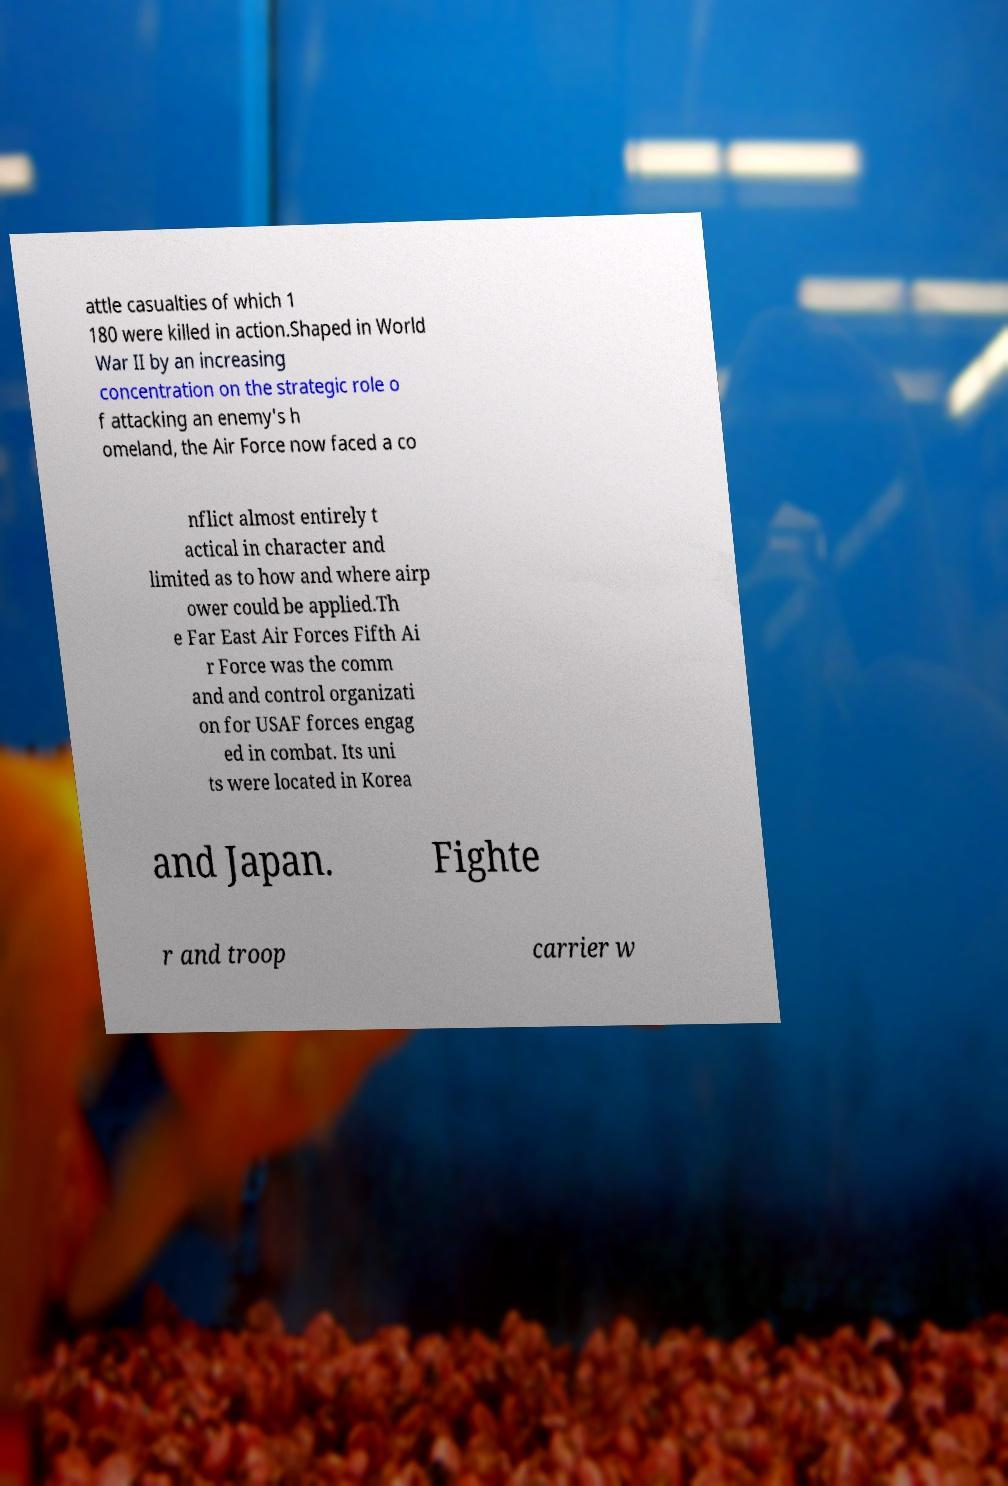Can you read and provide the text displayed in the image?This photo seems to have some interesting text. Can you extract and type it out for me? attle casualties of which 1 180 were killed in action.Shaped in World War II by an increasing concentration on the strategic role o f attacking an enemy's h omeland, the Air Force now faced a co nflict almost entirely t actical in character and limited as to how and where airp ower could be applied.Th e Far East Air Forces Fifth Ai r Force was the comm and and control organizati on for USAF forces engag ed in combat. Its uni ts were located in Korea and Japan. Fighte r and troop carrier w 